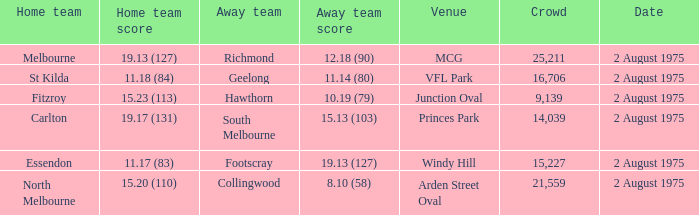What did the away team score when playing North Melbourne? 8.10 (58). 